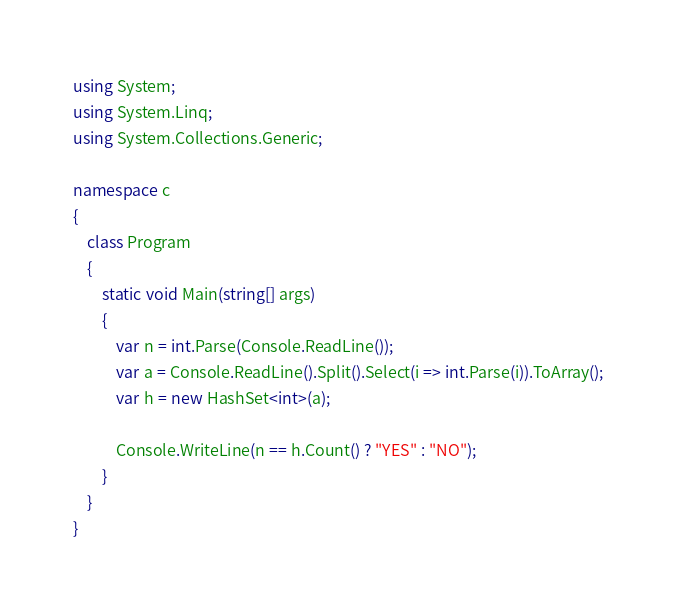Convert code to text. <code><loc_0><loc_0><loc_500><loc_500><_C#_>using System;
using System.Linq;
using System.Collections.Generic;

namespace c
{
    class Program
    {
        static void Main(string[] args)
        {
            var n = int.Parse(Console.ReadLine());
            var a = Console.ReadLine().Split().Select(i => int.Parse(i)).ToArray();
            var h = new HashSet<int>(a);

            Console.WriteLine(n == h.Count() ? "YES" : "NO");
        }
    }
}
</code> 